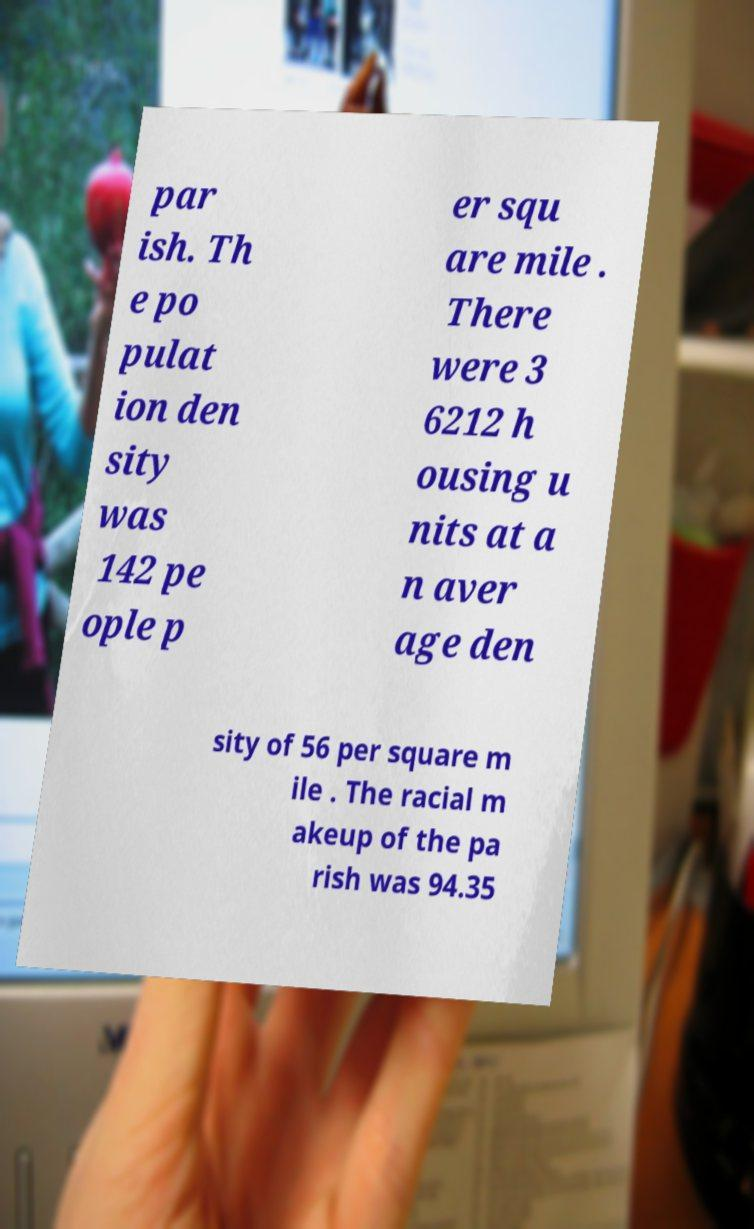Can you accurately transcribe the text from the provided image for me? par ish. Th e po pulat ion den sity was 142 pe ople p er squ are mile . There were 3 6212 h ousing u nits at a n aver age den sity of 56 per square m ile . The racial m akeup of the pa rish was 94.35 